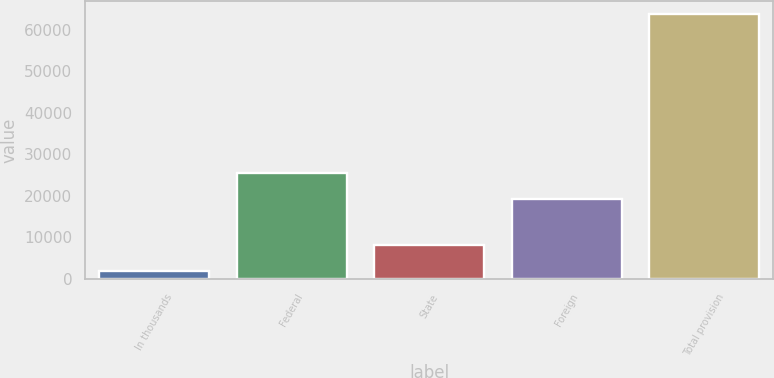Convert chart to OTSL. <chart><loc_0><loc_0><loc_500><loc_500><bar_chart><fcel>In thousands<fcel>Federal<fcel>State<fcel>Foreign<fcel>Total provision<nl><fcel>2010<fcel>25410.8<fcel>8181.8<fcel>19239<fcel>63728<nl></chart> 